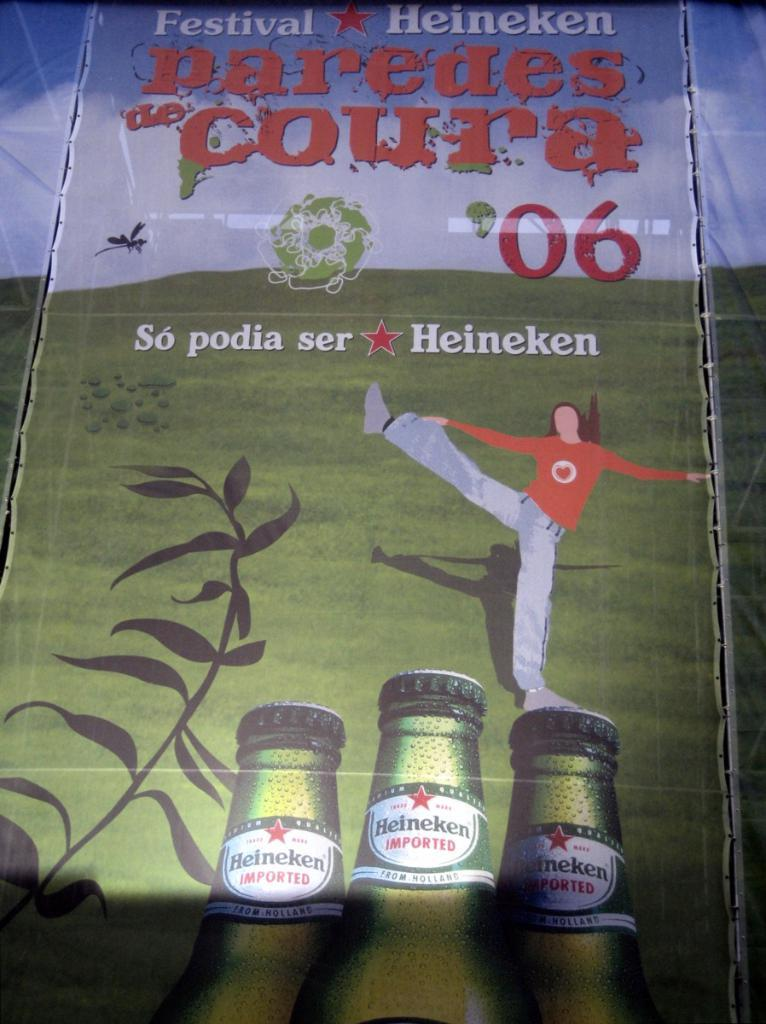What is featured on the banners in the image? The banners contain a picture of a cartoon person, wine bottles, a plant, and grass on the ground. What else can be seen on the banners? The banners have texts and a sky with clouds visible in the background. How many different elements are depicted on the banners? There are at least six different elements depicted on the banners: a cartoon person, wine bottles, a plant, grass on the ground, texts, and a sky with clouds. Can you describe the mountain range visible in the background of the banners? There is no mountain range visible in the background of the banners; the background features a sky with clouds. What type of detail can be seen on the alley depicted on the banners? There is no alley depicted on the banners; the banners show a cartoon person, wine bottles, a plant, grass on the ground, texts, and a sky with clouds. 